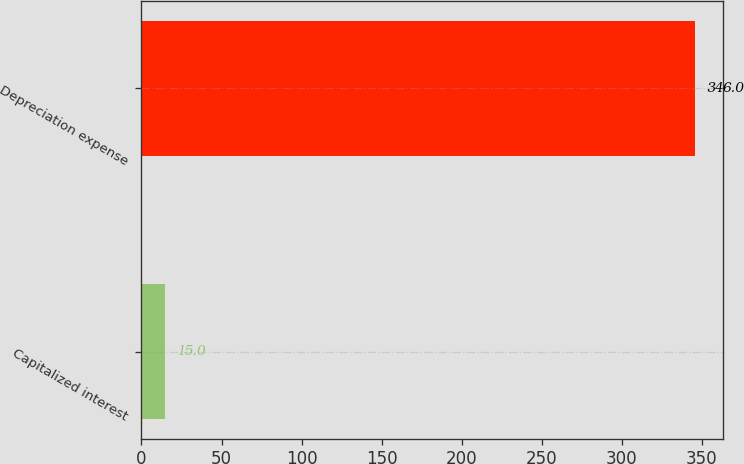<chart> <loc_0><loc_0><loc_500><loc_500><bar_chart><fcel>Capitalized interest<fcel>Depreciation expense<nl><fcel>15<fcel>346<nl></chart> 